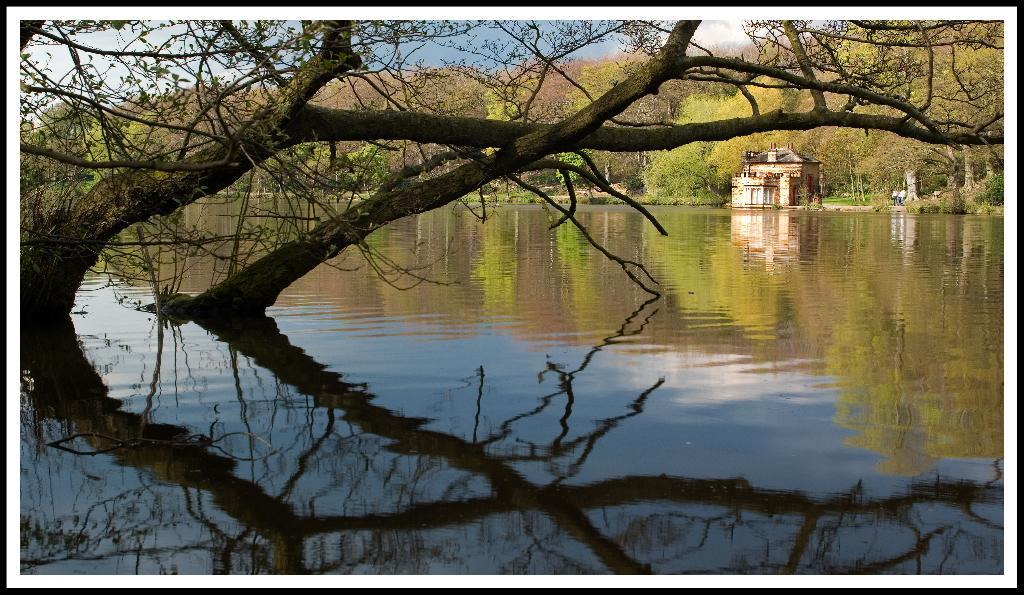What type of vegetation can be seen in the image? There are trees in the image. What type of structure is present in the image? There is a building in the image. What natural element is visible in the image? There is water visible in the image. How would you describe the sky in the image? The sky is blue and cloudy. Where is the kitty playing in the image? There is no kitty present in the image. What is the interest rate of the loan mentioned in the image? There is no mention of a loan or interest rate in the image. 